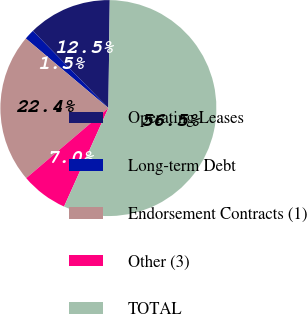<chart> <loc_0><loc_0><loc_500><loc_500><pie_chart><fcel>Operating Leases<fcel>Long-term Debt<fcel>Endorsement Contracts (1)<fcel>Other (3)<fcel>TOTAL<nl><fcel>12.53%<fcel>1.53%<fcel>22.38%<fcel>7.03%<fcel>56.53%<nl></chart> 